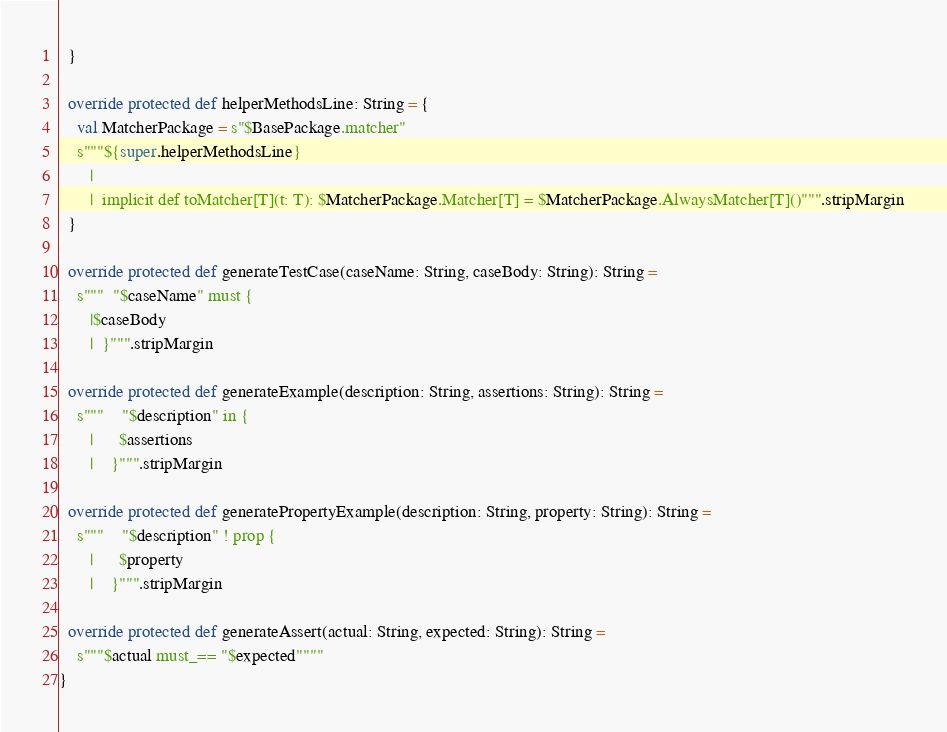<code> <loc_0><loc_0><loc_500><loc_500><_Scala_>  }

  override protected def helperMethodsLine: String = {
    val MatcherPackage = s"$BasePackage.matcher"
    s"""${super.helperMethodsLine}
       |
       |  implicit def toMatcher[T](t: T): $MatcherPackage.Matcher[T] = $MatcherPackage.AlwaysMatcher[T]()""".stripMargin
  }

  override protected def generateTestCase(caseName: String, caseBody: String): String =
    s"""  "$caseName" must {
       |$caseBody
       |  }""".stripMargin

  override protected def generateExample(description: String, assertions: String): String =
    s"""    "$description" in {
       |      $assertions
       |    }""".stripMargin

  override protected def generatePropertyExample(description: String, property: String): String =
    s"""    "$description" ! prop {
       |      $property
       |    }""".stripMargin

  override protected def generateAssert(actual: String, expected: String): String =
    s"""$actual must_== "$expected""""
}
</code> 